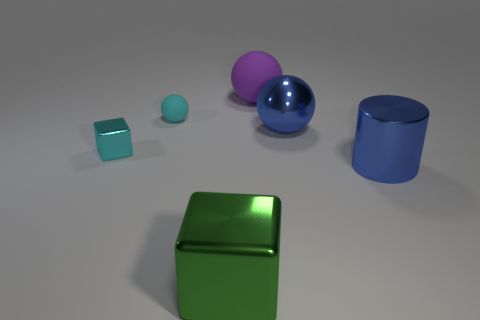Subtract all big balls. How many balls are left? 1 Add 1 green shiny cubes. How many objects exist? 7 Subtract all cyan balls. How many balls are left? 2 Subtract all blocks. How many objects are left? 4 Subtract 1 balls. How many balls are left? 2 Subtract all blue balls. Subtract all gray cylinders. How many balls are left? 2 Subtract all big blue metal cylinders. Subtract all blue metal things. How many objects are left? 3 Add 2 tiny cyan balls. How many tiny cyan balls are left? 3 Add 1 big red cubes. How many big red cubes exist? 1 Subtract 1 blue cylinders. How many objects are left? 5 